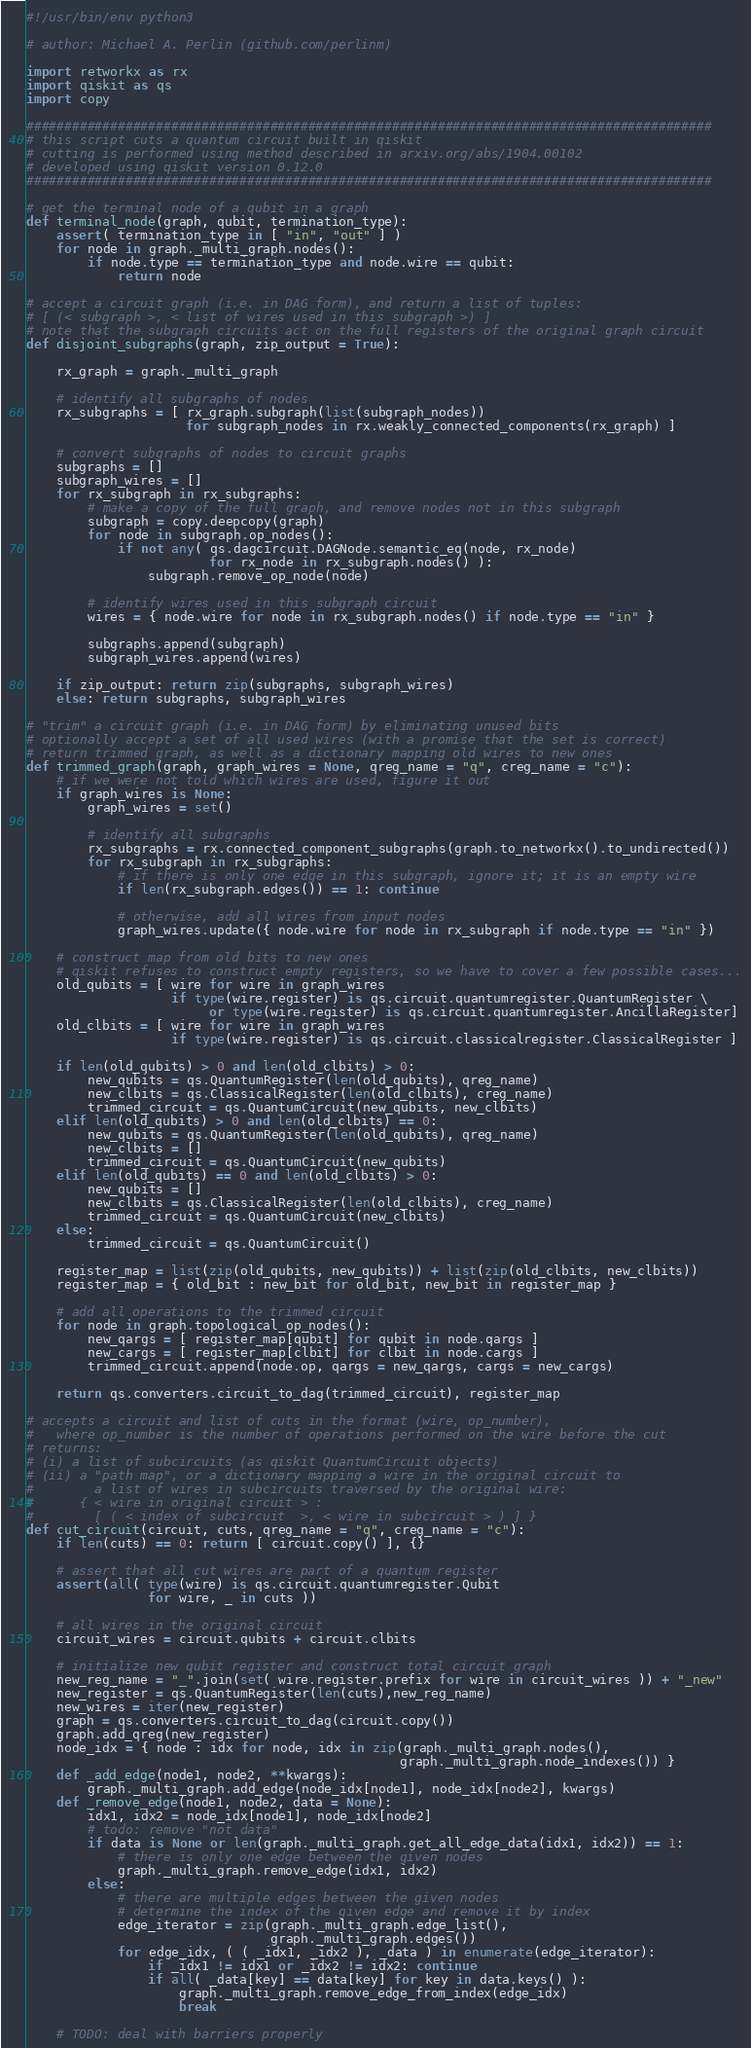Convert code to text. <code><loc_0><loc_0><loc_500><loc_500><_Python_>#!/usr/bin/env python3

# author: Michael A. Perlin (github.com/perlinm)

import retworkx as rx
import qiskit as qs
import copy

##########################################################################################
# this script cuts a quantum circuit built in qiskit
# cutting is performed using method described in arxiv.org/abs/1904.00102
# developed using qiskit version 0.12.0
##########################################################################################

# get the terminal node of a qubit in a graph
def terminal_node(graph, qubit, termination_type):
    assert( termination_type in [ "in", "out" ] )
    for node in graph._multi_graph.nodes():
        if node.type == termination_type and node.wire == qubit:
            return node

# accept a circuit graph (i.e. in DAG form), and return a list of tuples:
# [ (< subgraph >, < list of wires used in this subgraph >) ]
# note that the subgraph circuits act on the full registers of the original graph circuit
def disjoint_subgraphs(graph, zip_output = True):

    rx_graph = graph._multi_graph

    # identify all subgraphs of nodes
    rx_subgraphs = [ rx_graph.subgraph(list(subgraph_nodes))
                     for subgraph_nodes in rx.weakly_connected_components(rx_graph) ]

    # convert subgraphs of nodes to circuit graphs
    subgraphs = []
    subgraph_wires = []
    for rx_subgraph in rx_subgraphs:
        # make a copy of the full graph, and remove nodes not in this subgraph
        subgraph = copy.deepcopy(graph)
        for node in subgraph.op_nodes():
            if not any( qs.dagcircuit.DAGNode.semantic_eq(node, rx_node)
                        for rx_node in rx_subgraph.nodes() ):
                subgraph.remove_op_node(node)

        # identify wires used in this subgraph circuit
        wires = { node.wire for node in rx_subgraph.nodes() if node.type == "in" }

        subgraphs.append(subgraph)
        subgraph_wires.append(wires)

    if zip_output: return zip(subgraphs, subgraph_wires)
    else: return subgraphs, subgraph_wires

# "trim" a circuit graph (i.e. in DAG form) by eliminating unused bits
# optionally accept a set of all used wires (with a promise that the set is correct)
# return trimmed graph, as well as a dictionary mapping old wires to new ones
def trimmed_graph(graph, graph_wires = None, qreg_name = "q", creg_name = "c"):
    # if we were not told which wires are used, figure it out
    if graph_wires is None:
        graph_wires = set()

        # identify all subgraphs
        rx_subgraphs = rx.connected_component_subgraphs(graph.to_networkx().to_undirected())
        for rx_subgraph in rx_subgraphs:
            # if there is only one edge in this subgraph, ignore it; it is an empty wire
            if len(rx_subgraph.edges()) == 1: continue

            # otherwise, add all wires from input nodes
            graph_wires.update({ node.wire for node in rx_subgraph if node.type == "in" })

    # construct map from old bits to new ones
    # qiskit refuses to construct empty registers, so we have to cover a few possible cases...
    old_qubits = [ wire for wire in graph_wires
                   if type(wire.register) is qs.circuit.quantumregister.QuantumRegister \
                        or type(wire.register) is qs.circuit.quantumregister.AncillaRegister]
    old_clbits = [ wire for wire in graph_wires
                   if type(wire.register) is qs.circuit.classicalregister.ClassicalRegister ]

    if len(old_qubits) > 0 and len(old_clbits) > 0:
        new_qubits = qs.QuantumRegister(len(old_qubits), qreg_name)
        new_clbits = qs.ClassicalRegister(len(old_clbits), creg_name)
        trimmed_circuit = qs.QuantumCircuit(new_qubits, new_clbits)
    elif len(old_qubits) > 0 and len(old_clbits) == 0:
        new_qubits = qs.QuantumRegister(len(old_qubits), qreg_name)
        new_clbits = []
        trimmed_circuit = qs.QuantumCircuit(new_qubits)
    elif len(old_qubits) == 0 and len(old_clbits) > 0:
        new_qubits = []
        new_clbits = qs.ClassicalRegister(len(old_clbits), creg_name)
        trimmed_circuit = qs.QuantumCircuit(new_clbits)
    else:
        trimmed_circuit = qs.QuantumCircuit()

    register_map = list(zip(old_qubits, new_qubits)) + list(zip(old_clbits, new_clbits))
    register_map = { old_bit : new_bit for old_bit, new_bit in register_map }

    # add all operations to the trimmed circuit
    for node in graph.topological_op_nodes():
        new_qargs = [ register_map[qubit] for qubit in node.qargs ]
        new_cargs = [ register_map[clbit] for clbit in node.cargs ]
        trimmed_circuit.append(node.op, qargs = new_qargs, cargs = new_cargs)

    return qs.converters.circuit_to_dag(trimmed_circuit), register_map

# accepts a circuit and list of cuts in the format (wire, op_number),
#   where op_number is the number of operations performed on the wire before the cut
# returns:
# (i) a list of subcircuits (as qiskit QuantumCircuit objects)
# (ii) a "path map", or a dictionary mapping a wire in the original circuit to
#        a list of wires in subcircuits traversed by the original wire:
#      { < wire in original circuit > :
#        [ ( < index of subcircuit  >, < wire in subcircuit > ) ] }
def cut_circuit(circuit, cuts, qreg_name = "q", creg_name = "c"):
    if len(cuts) == 0: return [ circuit.copy() ], {}

    # assert that all cut wires are part of a quantum register
    assert(all( type(wire) is qs.circuit.quantumregister.Qubit
                for wire, _ in cuts ))

    # all wires in the original circuit
    circuit_wires = circuit.qubits + circuit.clbits

    # initialize new qubit register and construct total circuit graph
    new_reg_name = "_".join(set( wire.register.prefix for wire in circuit_wires )) + "_new"
    new_register = qs.QuantumRegister(len(cuts),new_reg_name)
    new_wires = iter(new_register)
    graph = qs.converters.circuit_to_dag(circuit.copy())
    graph.add_qreg(new_register)
    node_idx = { node : idx for node, idx in zip(graph._multi_graph.nodes(),
                                                 graph._multi_graph.node_indexes()) }
    def _add_edge(node1, node2, **kwargs):
        graph._multi_graph.add_edge(node_idx[node1], node_idx[node2], kwargs)
    def _remove_edge(node1, node2, data = None):
        idx1, idx2 = node_idx[node1], node_idx[node2]
        # todo: remove "not data"
        if data is None or len(graph._multi_graph.get_all_edge_data(idx1, idx2)) == 1:
            # there is only one edge between the given nodes
            graph._multi_graph.remove_edge(idx1, idx2)
        else:
            # there are multiple edges between the given nodes
            # determine the index of the given edge and remove it by index
            edge_iterator = zip(graph._multi_graph.edge_list(),
                                graph._multi_graph.edges())
            for edge_idx, ( ( _idx1, _idx2 ), _data ) in enumerate(edge_iterator):
                if _idx1 != idx1 or _idx2 != idx2: continue
                if all( _data[key] == data[key] for key in data.keys() ):
                    graph._multi_graph.remove_edge_from_index(edge_idx)
                    break

    # TODO: deal with barriers properly</code> 